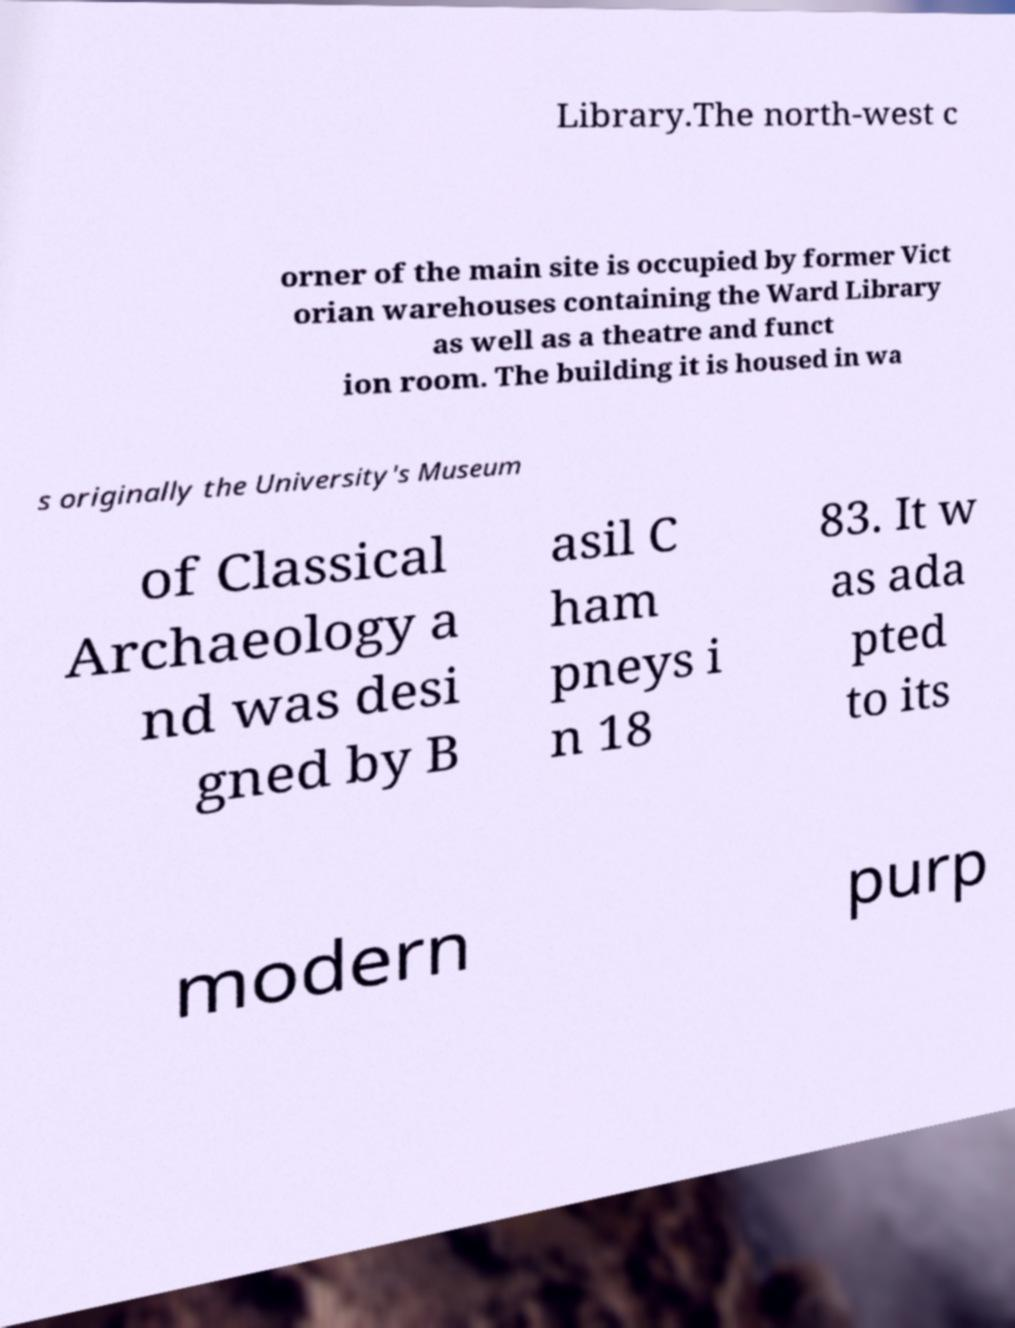Could you extract and type out the text from this image? Library.The north-west c orner of the main site is occupied by former Vict orian warehouses containing the Ward Library as well as a theatre and funct ion room. The building it is housed in wa s originally the University's Museum of Classical Archaeology a nd was desi gned by B asil C ham pneys i n 18 83. It w as ada pted to its modern purp 